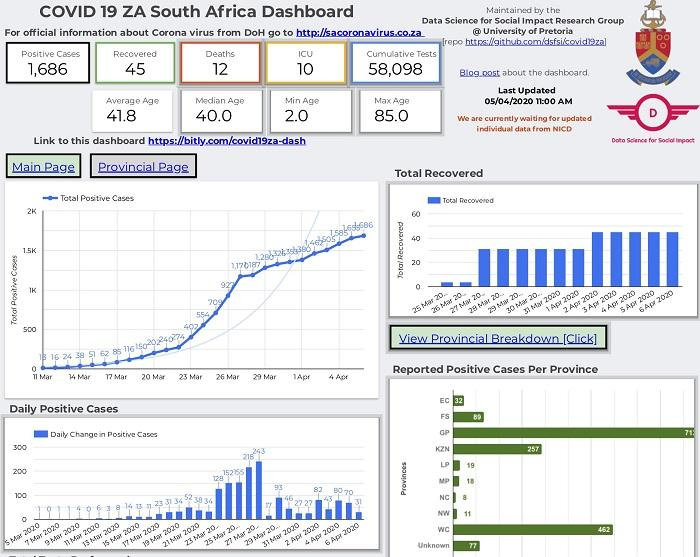Point out several critical features in this image. The average age is 41.8. The maximum age is 85 years old. The total number of cases on the 12th and 13th of March taken together is 40. The minimum age is 2.0. There were 12 reported deaths. 